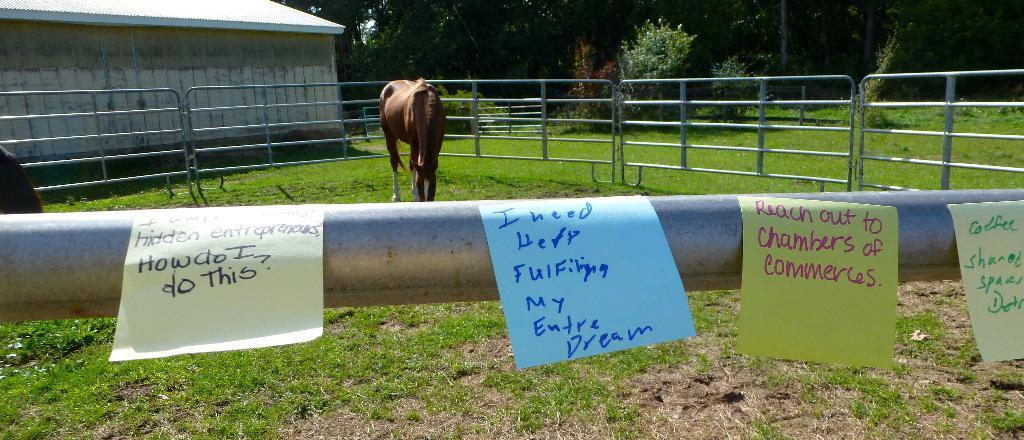How would you summarize this image in a sentence or two? There is an animal on the ground. Here we can see a fence, shed, grass, posters, and plants. In the background there are trees. 